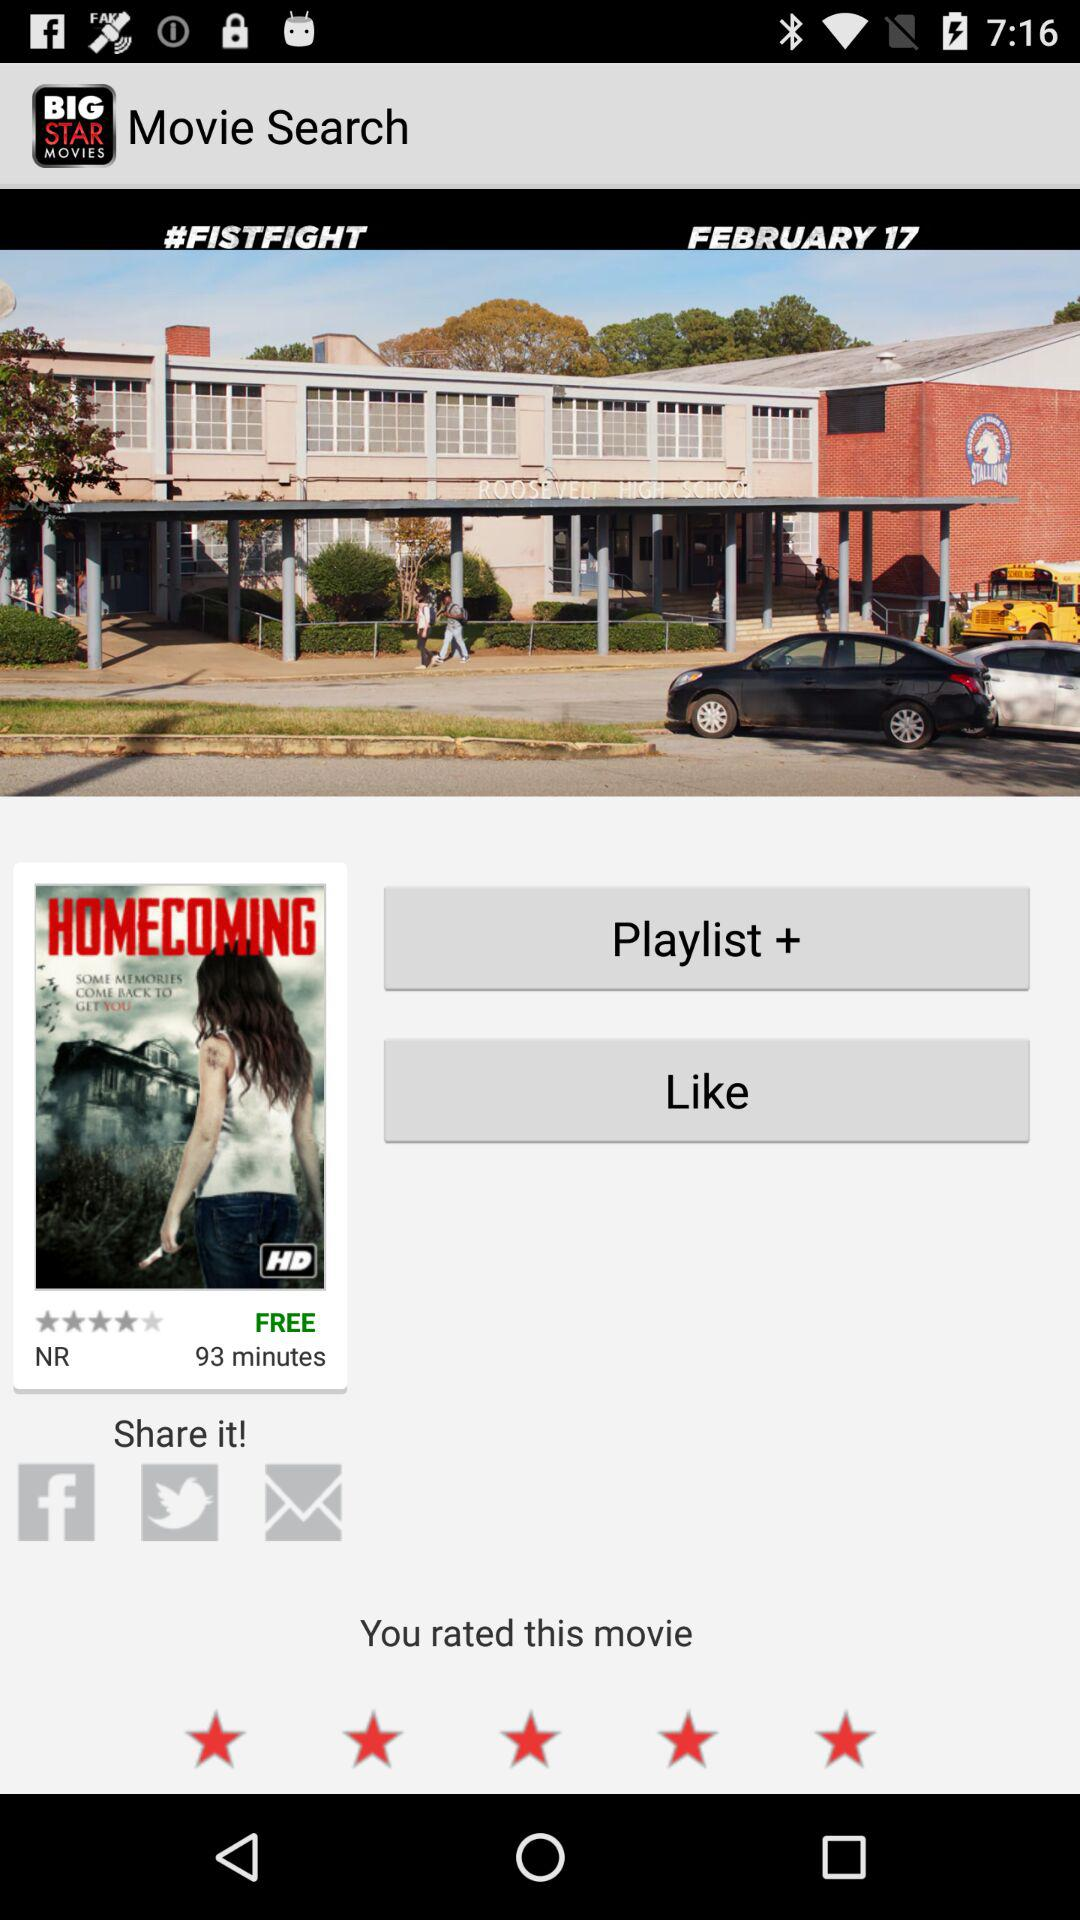What are the sharing options? The sharing options are "Facebook", "Twitter" and "Email". 